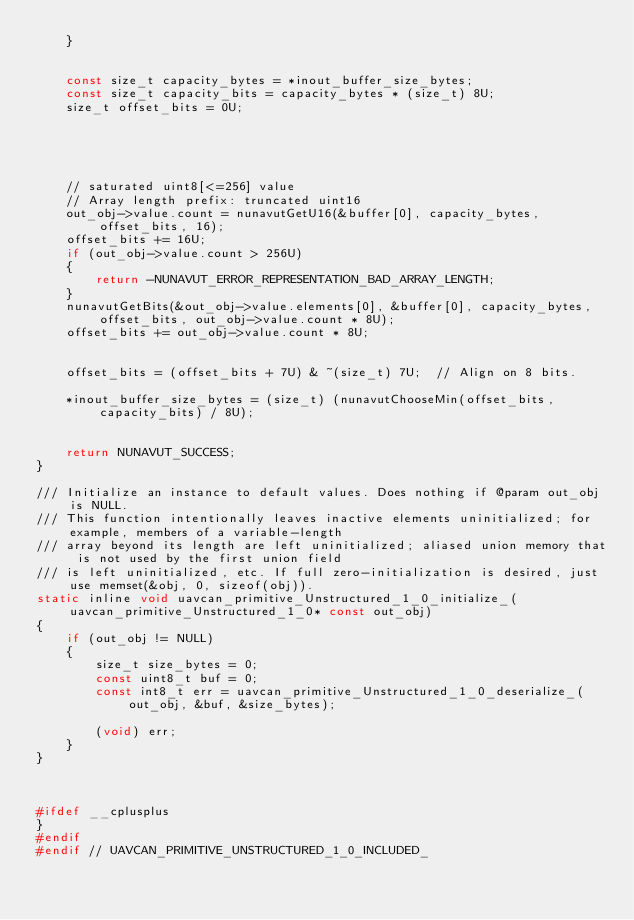<code> <loc_0><loc_0><loc_500><loc_500><_C_>    }


    const size_t capacity_bytes = *inout_buffer_size_bytes;
    const size_t capacity_bits = capacity_bytes * (size_t) 8U;
    size_t offset_bits = 0U;





    // saturated uint8[<=256] value
    // Array length prefix: truncated uint16
    out_obj->value.count = nunavutGetU16(&buffer[0], capacity_bytes, offset_bits, 16);
    offset_bits += 16U;
    if (out_obj->value.count > 256U)
    {
        return -NUNAVUT_ERROR_REPRESENTATION_BAD_ARRAY_LENGTH;
    }
    nunavutGetBits(&out_obj->value.elements[0], &buffer[0], capacity_bytes, offset_bits, out_obj->value.count * 8U);
    offset_bits += out_obj->value.count * 8U;


    offset_bits = (offset_bits + 7U) & ~(size_t) 7U;  // Align on 8 bits.

    *inout_buffer_size_bytes = (size_t) (nunavutChooseMin(offset_bits, capacity_bits) / 8U);


    return NUNAVUT_SUCCESS;
}

/// Initialize an instance to default values. Does nothing if @param out_obj is NULL.
/// This function intentionally leaves inactive elements uninitialized; for example, members of a variable-length
/// array beyond its length are left uninitialized; aliased union memory that is not used by the first union field
/// is left uninitialized, etc. If full zero-initialization is desired, just use memset(&obj, 0, sizeof(obj)).
static inline void uavcan_primitive_Unstructured_1_0_initialize_(uavcan_primitive_Unstructured_1_0* const out_obj)
{
    if (out_obj != NULL)
    {
        size_t size_bytes = 0;
        const uint8_t buf = 0;
        const int8_t err = uavcan_primitive_Unstructured_1_0_deserialize_(out_obj, &buf, &size_bytes);

        (void) err;
    }
}



#ifdef __cplusplus
}
#endif
#endif // UAVCAN_PRIMITIVE_UNSTRUCTURED_1_0_INCLUDED_
</code> 